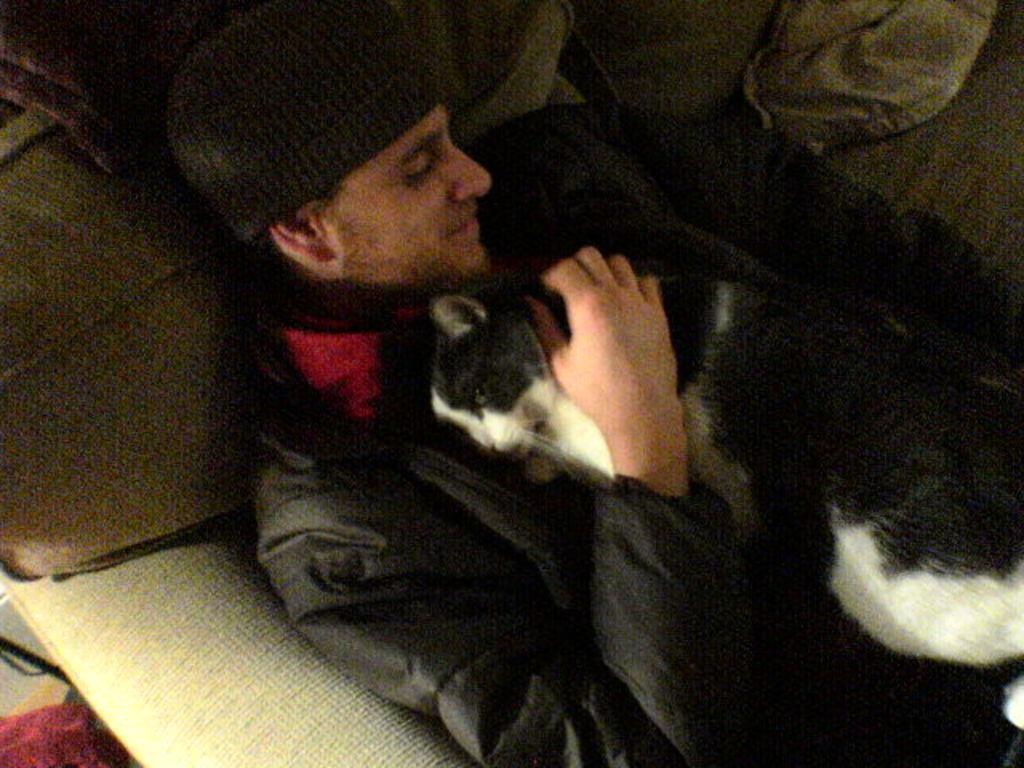What is the main subject of the image? There is a person in the image. What is the person holding in the image? The person is holding a black and white cat. What type of clothing is the person wearing? The person is wearing a black jacket. What type of headwear is the person wearing? The person is wearing a cap. What type of yard is visible in the image? There is no yard visible in the image; it features a person holding a cat. Is the person in the image a spy? There is no information in the image to suggest that the person is a spy. 